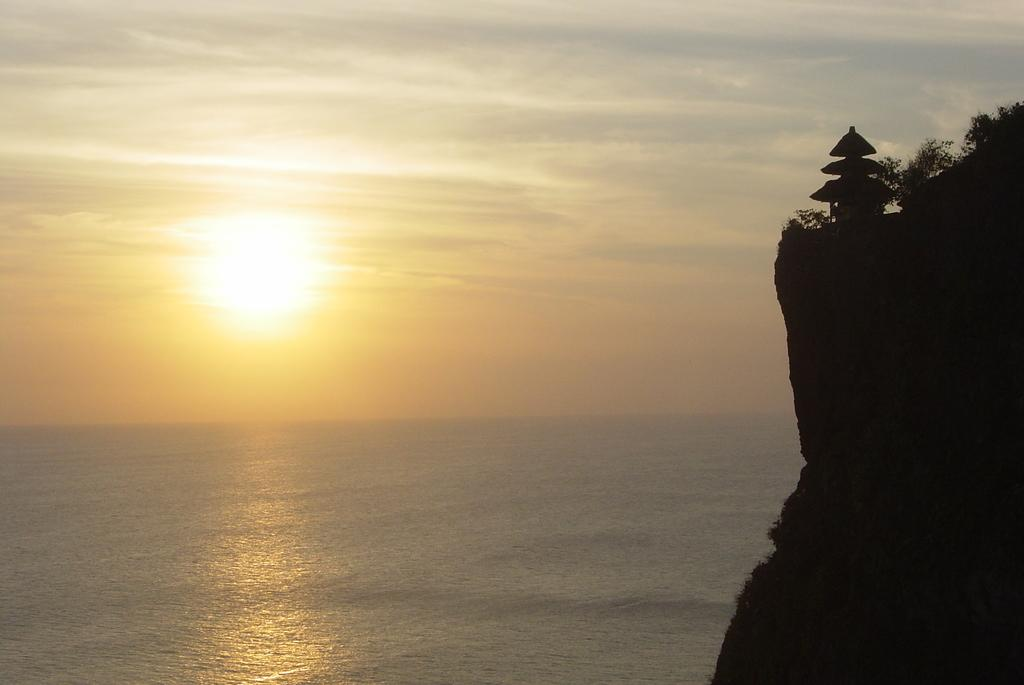What type of natural feature is on the left side of the image? There is an ocean on the left side of the image. What type of natural feature is on the right side of the image? There is a mountain on the right side of the image. What type of man-made structure is in the image? There is a building in the image. What type of vegetation is in the image? There are trees in the image. How would you describe the weather in the image? The sky is sunny and clear in the image. What type of produce is being harvested by the police in the image? There is no produce or police present in the image. What type of gardening tool is being used by the spade in the image? There is no spade present in the image. 